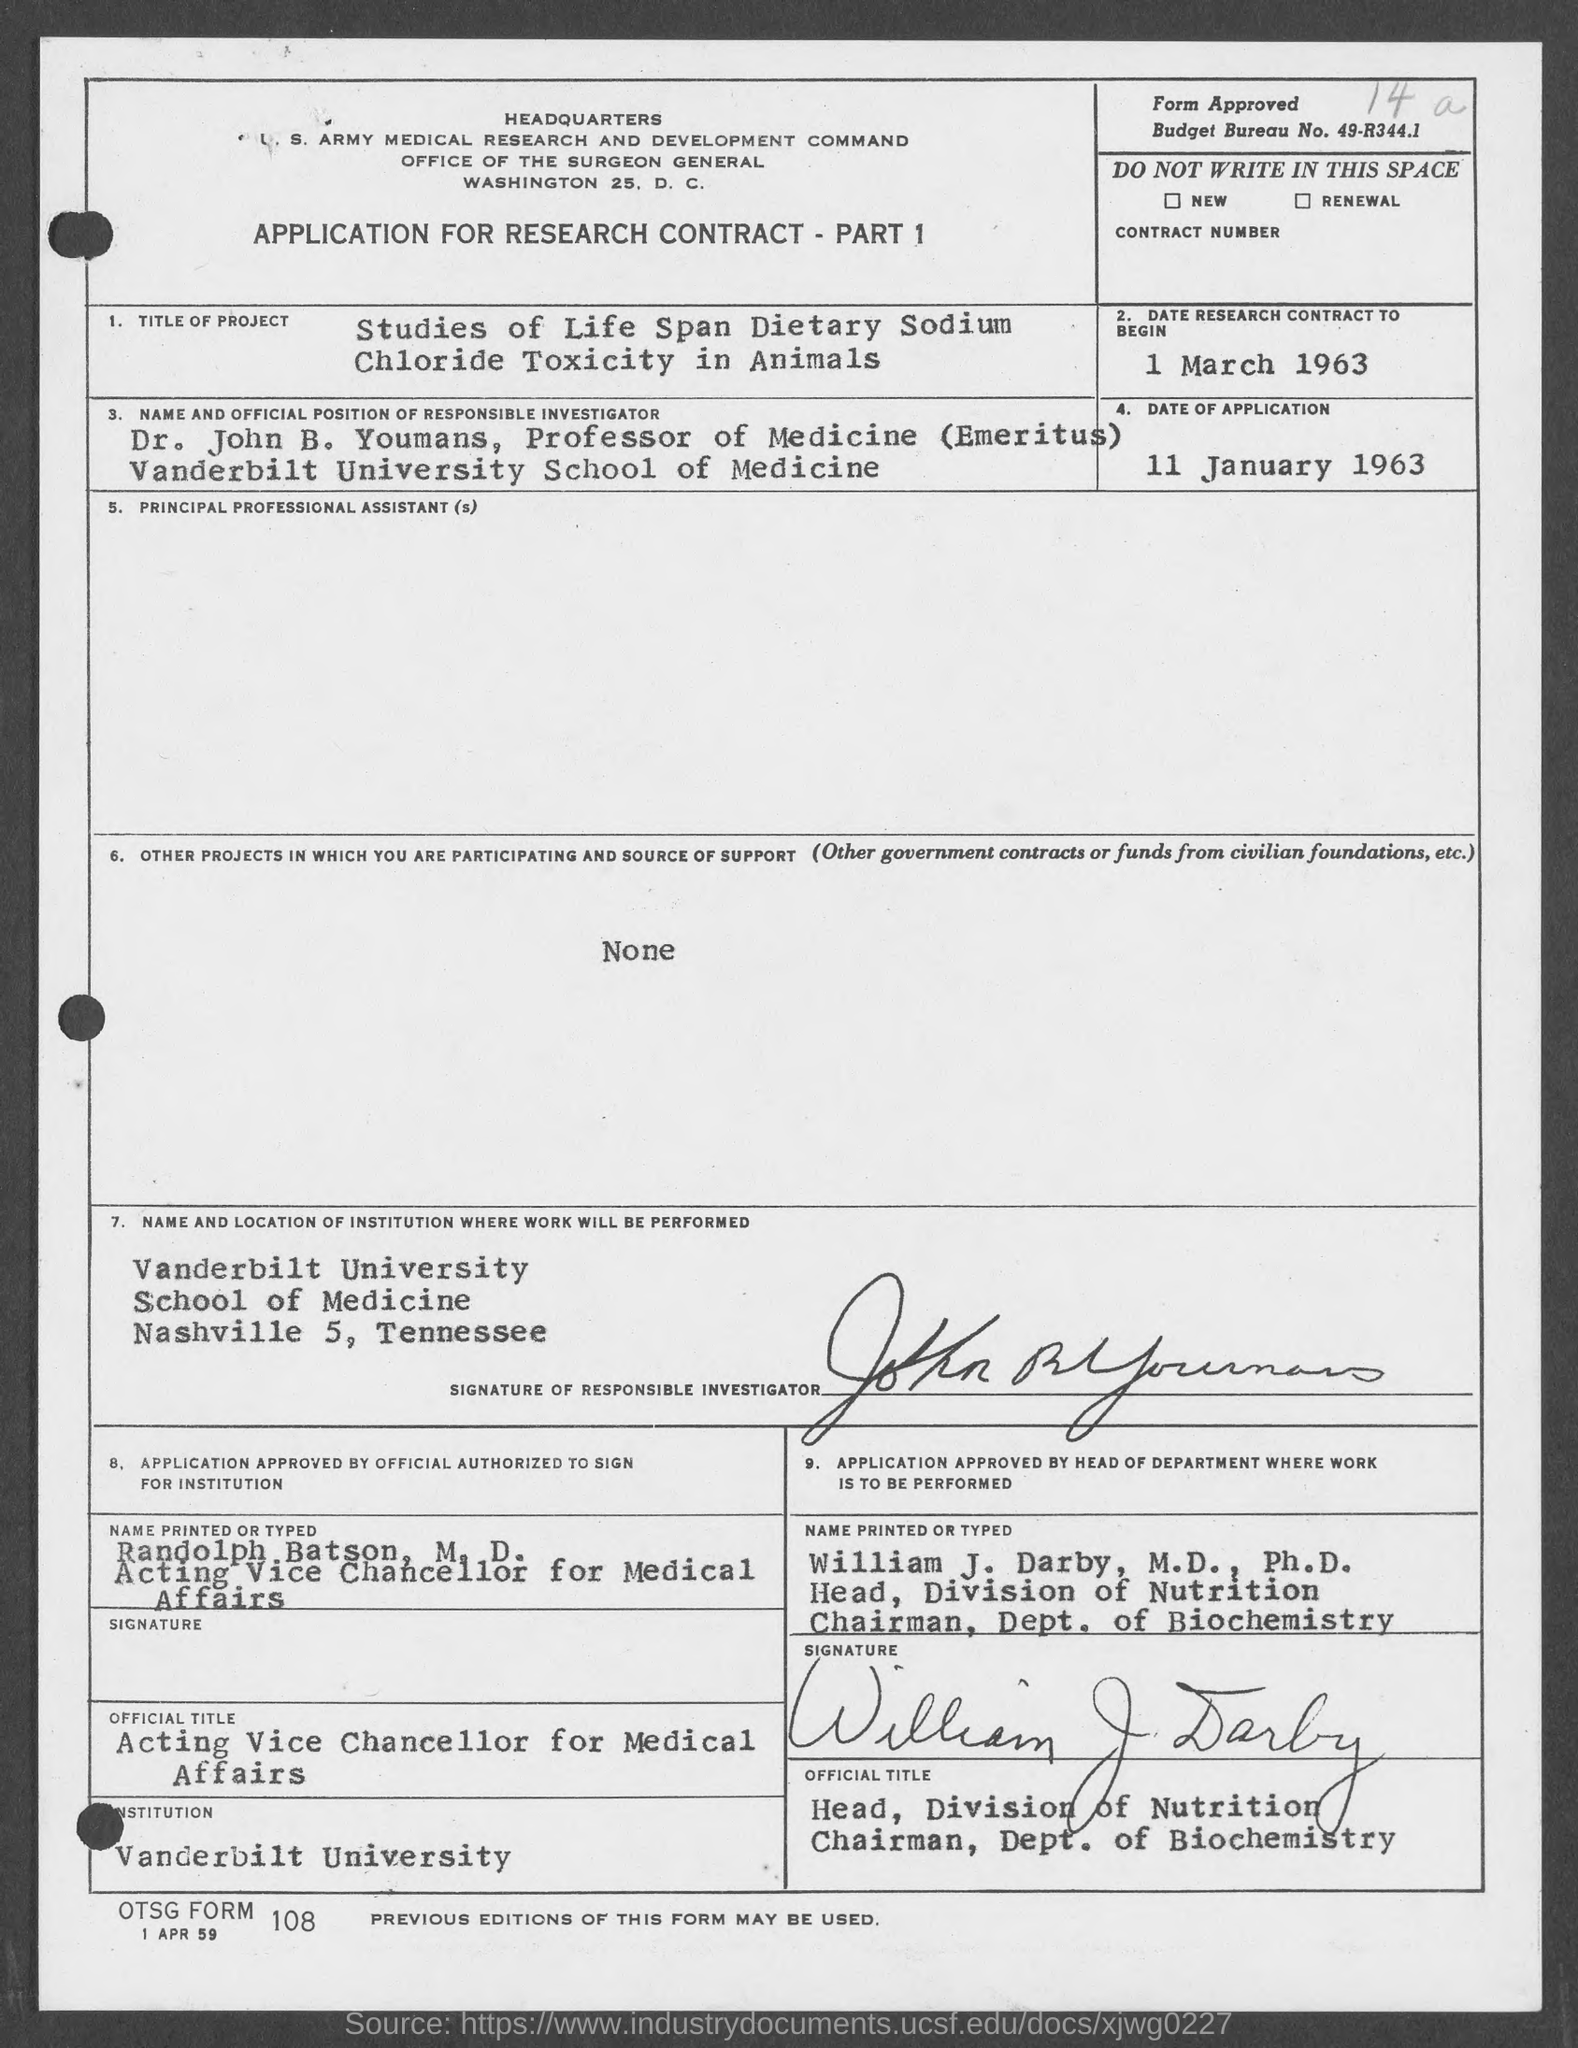Specify some key components in this picture. The date of application mentioned in the given form is January 11, 1963. The date of the research contract as mentioned on the given page is March 1, 1963. Vanderbilt University is a named institution mentioned in the given page. The given form contains a budget bureau number, which is 49-R344.1. The title of the project mentioned in the given form is "Life Span Dietary Sodium Chloride Toxicity in Animals. 